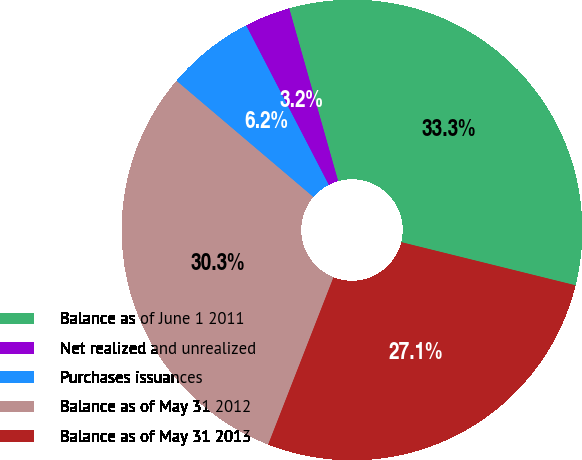Convert chart. <chart><loc_0><loc_0><loc_500><loc_500><pie_chart><fcel>Balance as of June 1 2011<fcel>Net realized and unrealized<fcel>Purchases issuances<fcel>Balance as of May 31 2012<fcel>Balance as of May 31 2013<nl><fcel>33.26%<fcel>3.21%<fcel>6.19%<fcel>30.28%<fcel>27.06%<nl></chart> 